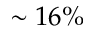<formula> <loc_0><loc_0><loc_500><loc_500>\sim 1 6 \%</formula> 